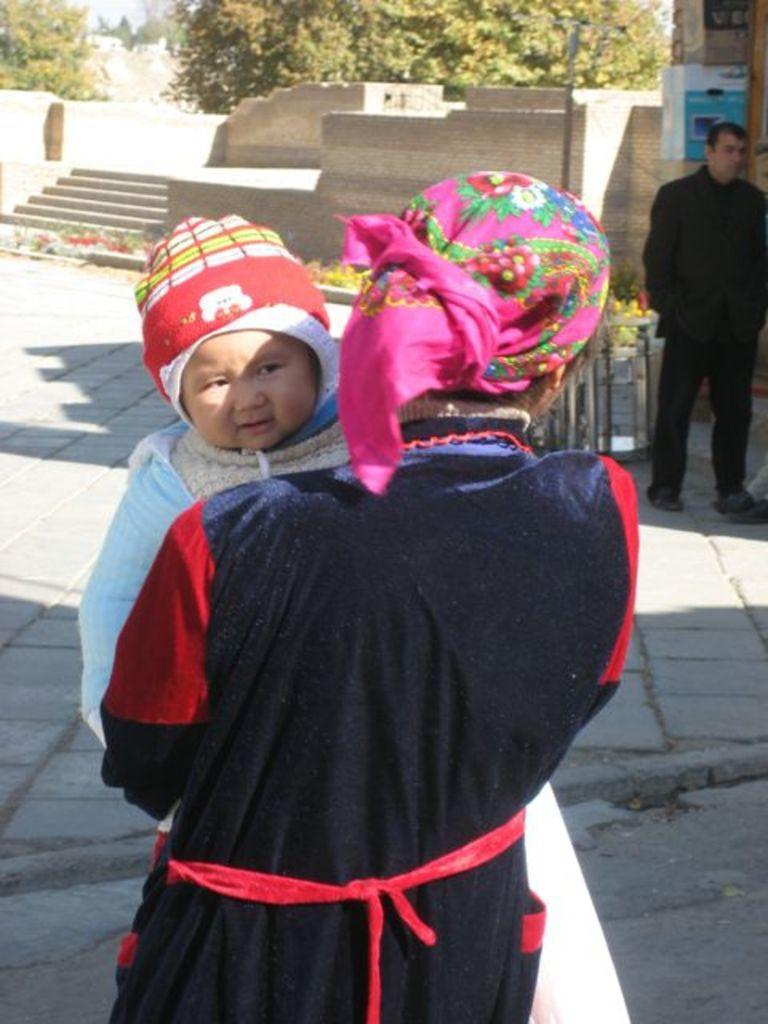Can you describe this image briefly? In this image I see a person who is carrying a baby and in the background I see the path and I see a man over here who is wearing black dress and I see few plants and steps over here and I see the wall and I see the trees. 